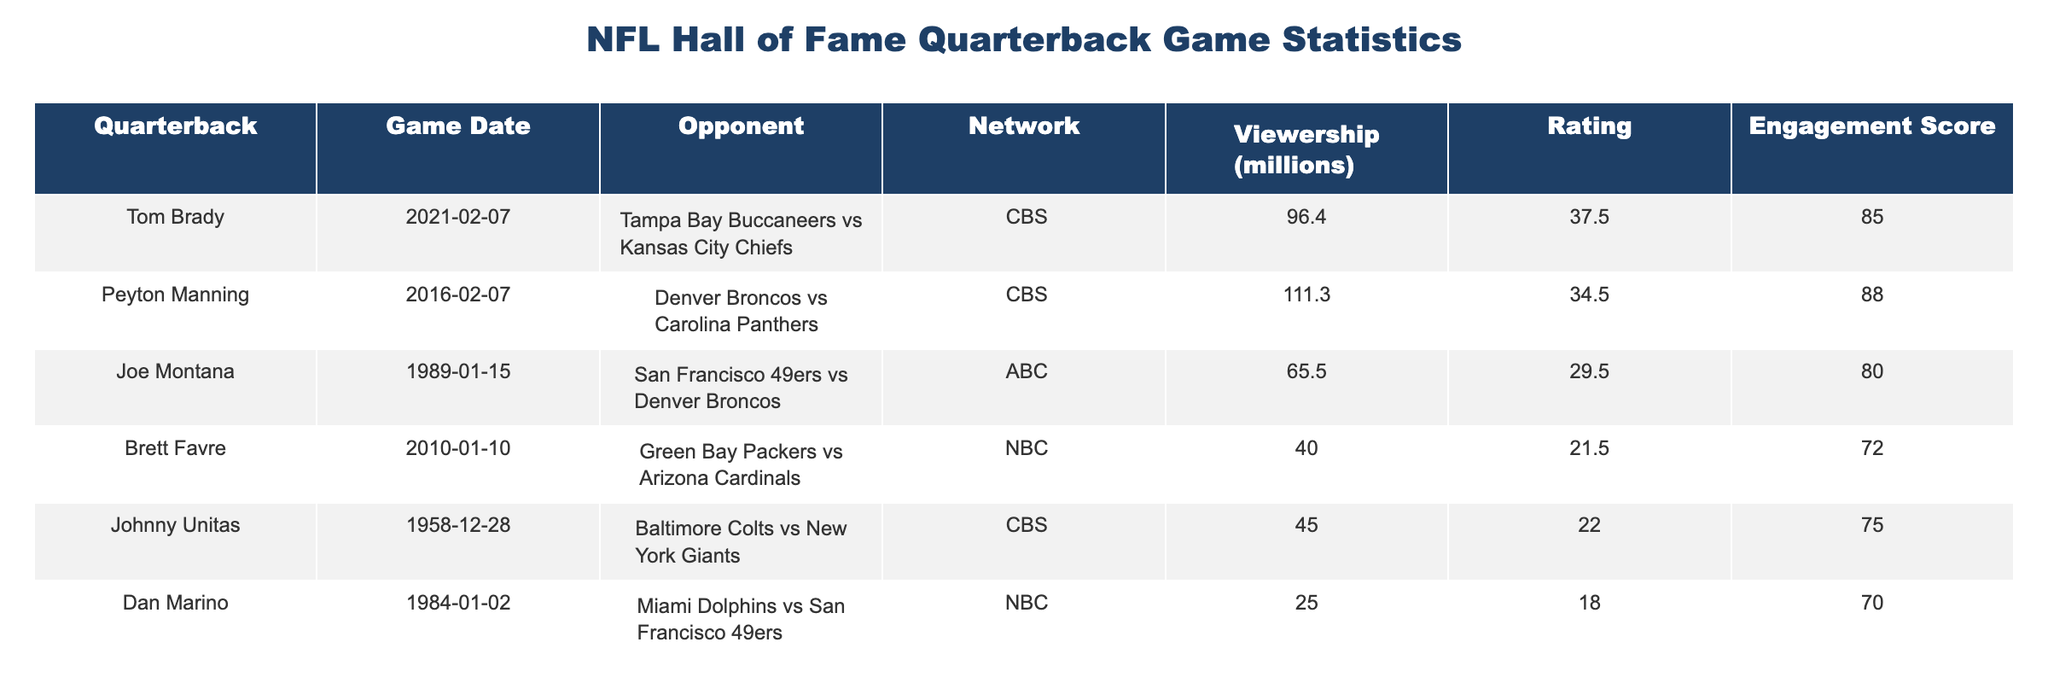What was the viewership for the game featuring Tom Brady? The viewership for the game where Tom Brady played was listed in the table as 96.4 million.
Answer: 96.4 million Which quarterback achieved the highest rating in the table? Looking at the rating column, Peyton Manning has the highest rating at 34.5, which is compared to the ratings of the other quarterbacks in the table.
Answer: Peyton Manning What is the engagement score of Joe Montana's game? The engagement score for Joe Montana's game is found in the corresponding row of the table, which shows a score of 80.
Answer: 80 What is the average viewership for the games played by the Hall of Fame quarterbacks listed? The viewership values for the games are 96.4, 111.3, 65.5, 40.0, 45.0, 25.0, and 42.0. Adding these gives 421.3 and dividing by 7 (the total number of games) results in an average of 60.19 million.
Answer: 60.19 million Did Drew Brees have a higher engagement score than Joe Montana? Checking the engagement score of Drew Brees (78) and comparing it to Joe Montana's score (80) shows that Drew Brees did not have a higher score.
Answer: No Which quarterback's game drew the least viewership? By reviewing the viewership numbers in the table, we see Dan Marino's game had the least viewership with 25.0 million.
Answer: Dan Marino Calculate the difference in engagement scores between the highest and lowest scores. The highest engagement score is Peyton Manning's at 88, and the lowest is Dan Marino's at 70. The difference is 88 - 70 = 18.
Answer: 18 If you combine the viewerships of Tom Brady and Peyton Manning, what would be the total? Tom Brady's viewership is 96.4 million and Peyton Manning's is 111.3 million. Adding these gives a total of 207.7 million.
Answer: 207.7 million Was Johnny Unitas's game viewed by more than 50 million people? The viewership for Johnny Unitas's game is 45.0 million, which is not more than 50 million.
Answer: No 